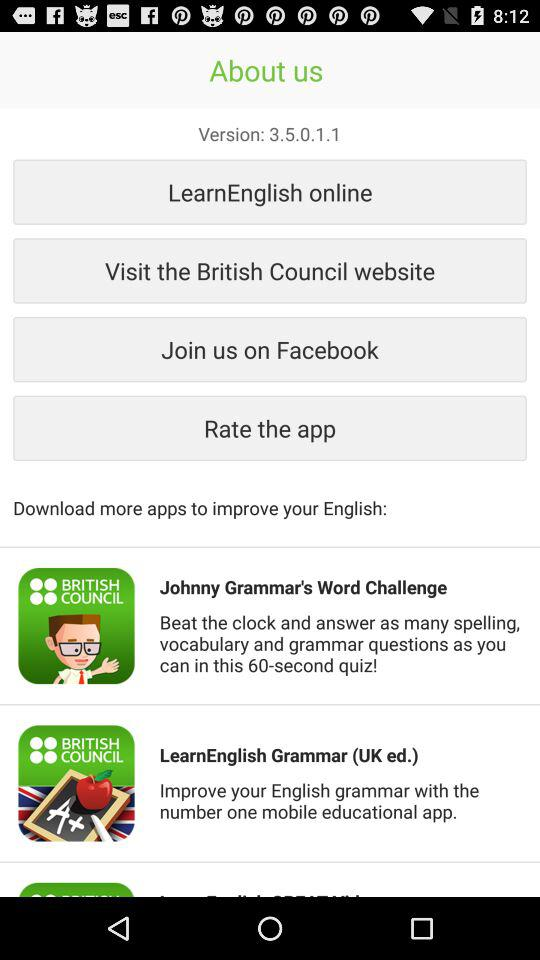How many LearnEnglish apps are available?
Answer the question using a single word or phrase. 2 